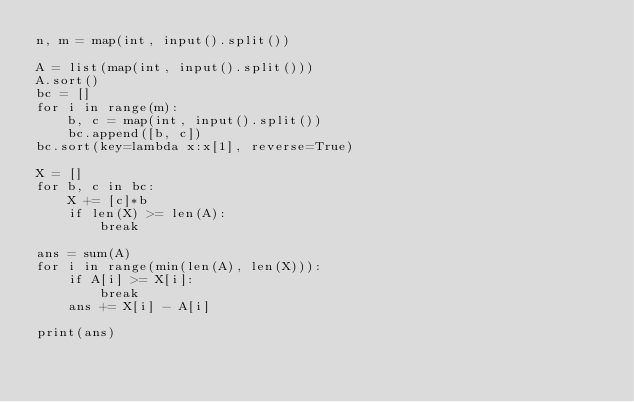Convert code to text. <code><loc_0><loc_0><loc_500><loc_500><_Python_>n, m = map(int, input().split())

A = list(map(int, input().split()))
A.sort()
bc = []
for i in range(m):
    b, c = map(int, input().split())
    bc.append([b, c])
bc.sort(key=lambda x:x[1], reverse=True)

X = []
for b, c in bc:
    X += [c]*b
    if len(X) >= len(A):
        break

ans = sum(A)
for i in range(min(len(A), len(X))):
    if A[i] >= X[i]:
        break
    ans += X[i] - A[i]

print(ans)</code> 